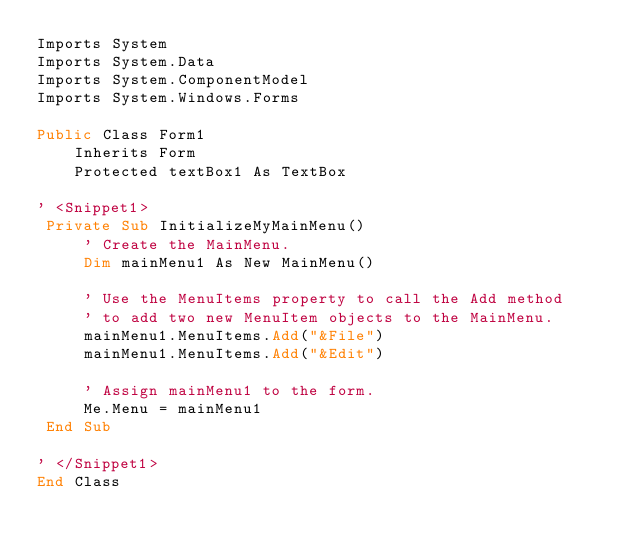<code> <loc_0><loc_0><loc_500><loc_500><_VisualBasic_>Imports System
Imports System.Data
Imports System.ComponentModel
Imports System.Windows.Forms

Public Class Form1
    Inherits Form
    Protected textBox1 As TextBox
    
' <Snippet1>
 Private Sub InitializeMyMainMenu()
     ' Create the MainMenu.
     Dim mainMenu1 As New MainMenu()
        
     ' Use the MenuItems property to call the Add method
     ' to add two new MenuItem objects to the MainMenu. 
     mainMenu1.MenuItems.Add("&File")
     mainMenu1.MenuItems.Add("&Edit")
        
     ' Assign mainMenu1 to the form.
     Me.Menu = mainMenu1
 End Sub

' </Snippet1> 
End Class

</code> 